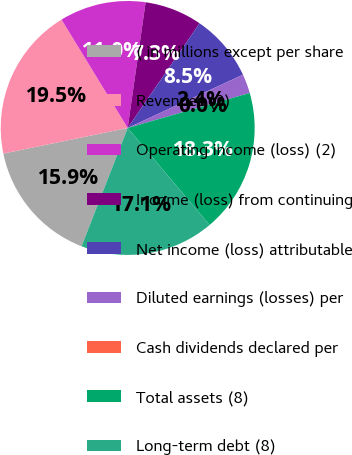Convert chart to OTSL. <chart><loc_0><loc_0><loc_500><loc_500><pie_chart><fcel>( in millions except per share<fcel>Revenues (2)<fcel>Operating income (loss) (2)<fcel>Income (loss) from continuing<fcel>Net income (loss) attributable<fcel>Diluted earnings (losses) per<fcel>Cash dividends declared per<fcel>Total assets (8)<fcel>Long-term debt (8)<nl><fcel>15.85%<fcel>19.51%<fcel>10.98%<fcel>7.32%<fcel>8.54%<fcel>2.44%<fcel>0.0%<fcel>18.29%<fcel>17.07%<nl></chart> 